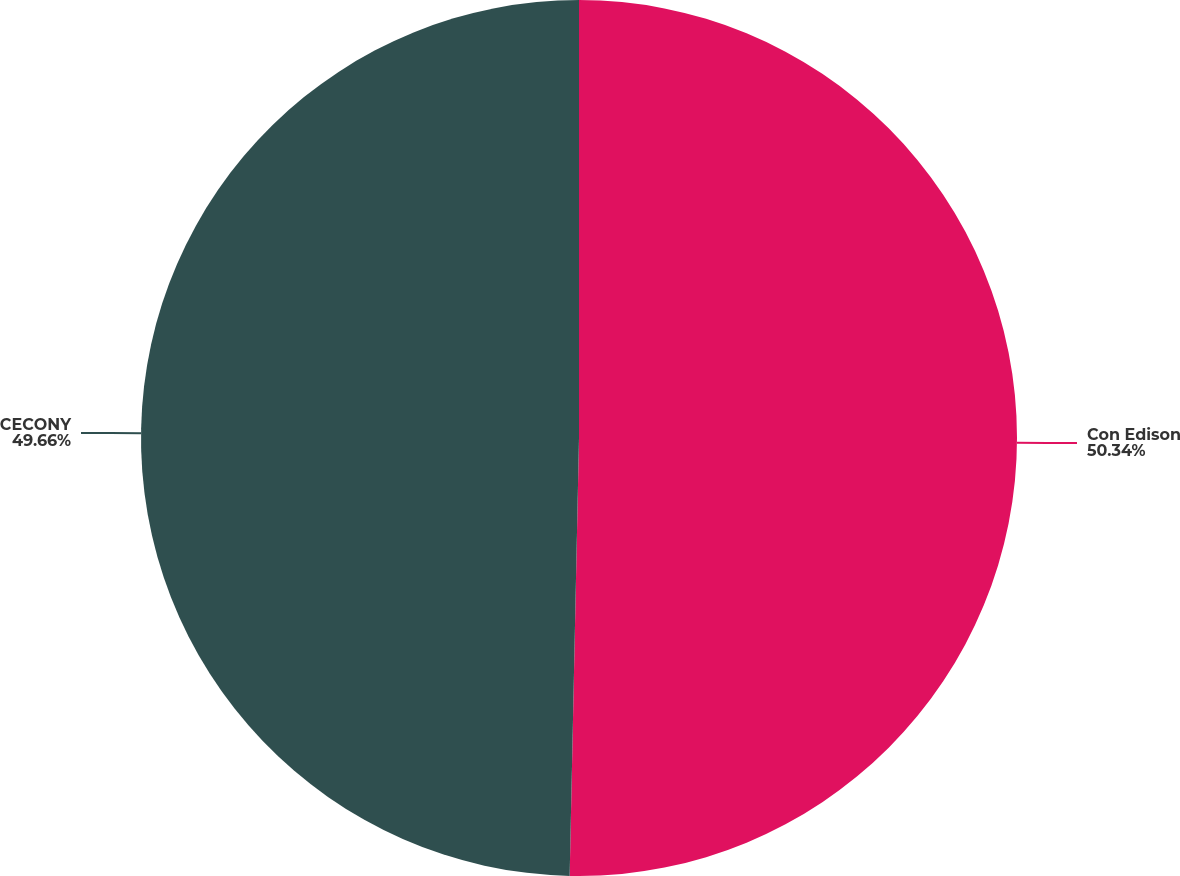Convert chart. <chart><loc_0><loc_0><loc_500><loc_500><pie_chart><fcel>Con Edison<fcel>CECONY<nl><fcel>50.34%<fcel>49.66%<nl></chart> 